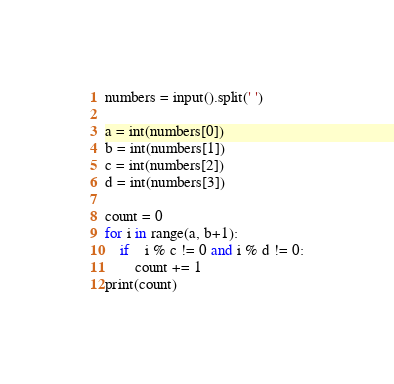Convert code to text. <code><loc_0><loc_0><loc_500><loc_500><_Python_>numbers = input().split(' ')

a = int(numbers[0])	
b = int(numbers[1])
c = int(numbers[2])
d = int(numbers[3])

count = 0
for i in range(a, b+1):
	if 	i % c != 0 and i % d != 0:
		count += 1
print(count)</code> 